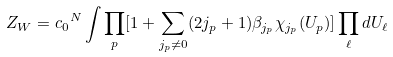<formula> <loc_0><loc_0><loc_500><loc_500>Z _ { W } = { c _ { 0 } } ^ { N } \int { \prod _ { p } [ 1 + \sum _ { j _ { p } \neq 0 } ( 2 j _ { p } + 1 ) \beta _ { j _ { p } } \chi _ { j _ { p } } ( U _ { p } ) ] } \prod _ { \ell } d U _ { \ell }</formula> 